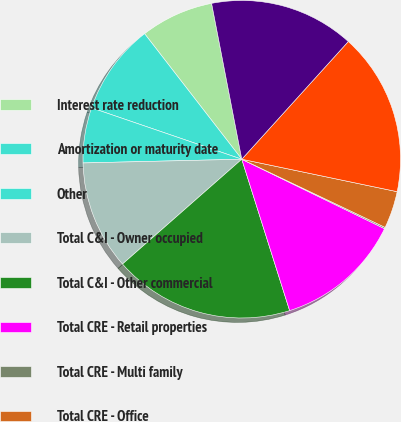Convert chart. <chart><loc_0><loc_0><loc_500><loc_500><pie_chart><fcel>Interest rate reduction<fcel>Amortization or maturity date<fcel>Other<fcel>Total C&I - Owner occupied<fcel>Total C&I - Other commercial<fcel>Total CRE - Retail properties<fcel>Total CRE - Multi family<fcel>Total CRE - Office<fcel>Total CRE - Industrial and<fcel>Total CRE - Other commercial<nl><fcel>7.44%<fcel>9.27%<fcel>5.62%<fcel>11.1%<fcel>18.4%<fcel>12.92%<fcel>0.14%<fcel>3.79%<fcel>16.57%<fcel>14.75%<nl></chart> 